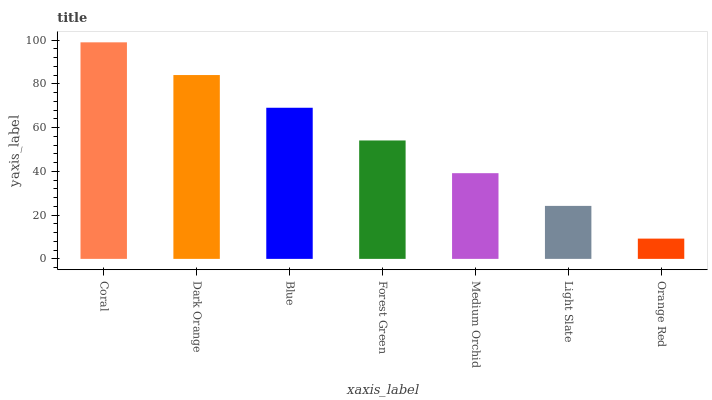Is Orange Red the minimum?
Answer yes or no. Yes. Is Coral the maximum?
Answer yes or no. Yes. Is Dark Orange the minimum?
Answer yes or no. No. Is Dark Orange the maximum?
Answer yes or no. No. Is Coral greater than Dark Orange?
Answer yes or no. Yes. Is Dark Orange less than Coral?
Answer yes or no. Yes. Is Dark Orange greater than Coral?
Answer yes or no. No. Is Coral less than Dark Orange?
Answer yes or no. No. Is Forest Green the high median?
Answer yes or no. Yes. Is Forest Green the low median?
Answer yes or no. Yes. Is Dark Orange the high median?
Answer yes or no. No. Is Dark Orange the low median?
Answer yes or no. No. 